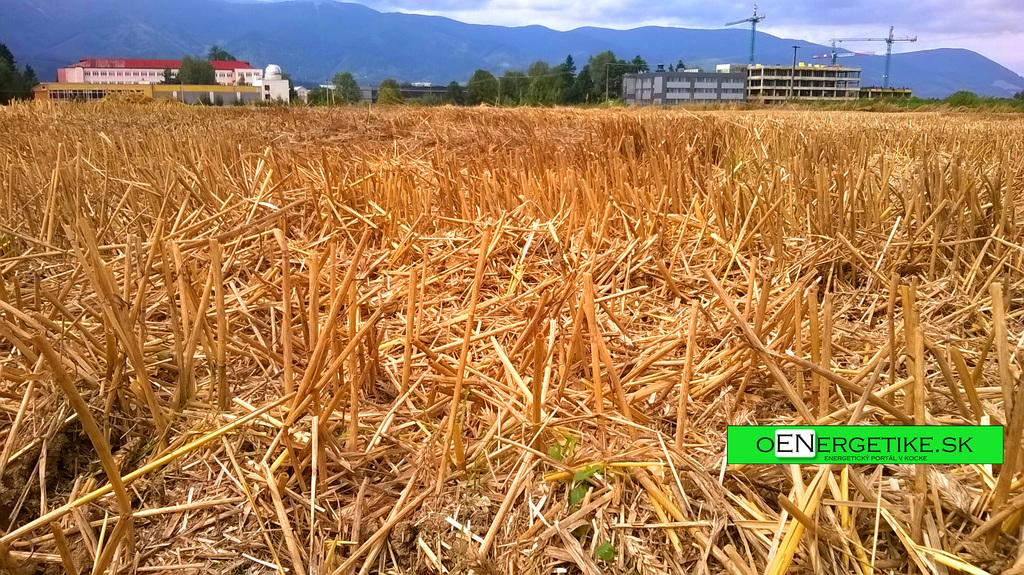What is located at the bottom of the image? There are plants at the bottom of the image. What can be seen in the background of the image? There are buildings, trees, poles, and mountains in the background of the image. What type of yarn is being used to create the mountains in the image? There is no yarn present in the image; the mountains are a natural formation. What kind of produce can be seen growing on the trees in the image? There is no produce visible on the trees in the image; only the trees themselves are present. 